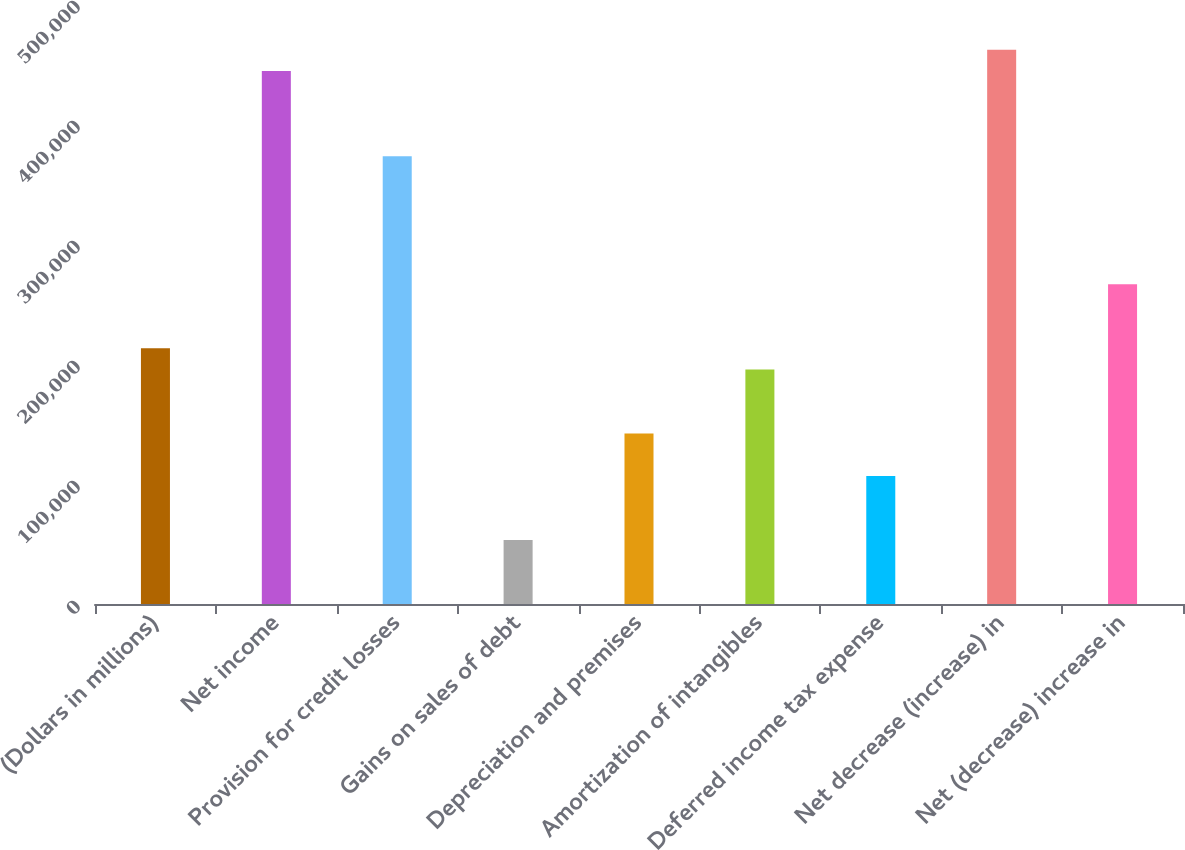Convert chart. <chart><loc_0><loc_0><loc_500><loc_500><bar_chart><fcel>(Dollars in millions)<fcel>Net income<fcel>Provision for credit losses<fcel>Gains on sales of debt<fcel>Depreciation and premises<fcel>Amortization of intangibles<fcel>Deferred income tax expense<fcel>Net decrease (increase) in<fcel>Net (decrease) increase in<nl><fcel>213190<fcel>444106<fcel>373055<fcel>53326.1<fcel>142140<fcel>195428<fcel>106614<fcel>461868<fcel>266478<nl></chart> 